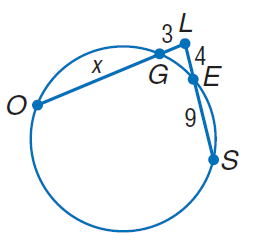Answer the mathemtical geometry problem and directly provide the correct option letter.
Question: Find x. Round to the nearest tenth, if necessary.
Choices: A: 3 B: 4 C: 9 D: 14.3 D 